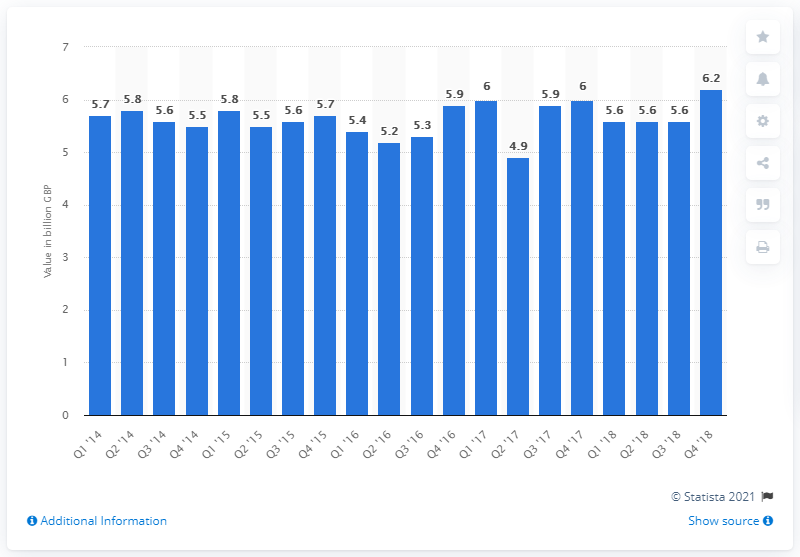Mention a couple of crucial points in this snapshot. The total claims of general insurance companies as of the fourth quarter of 2018 were approximately 6.2 billion. 